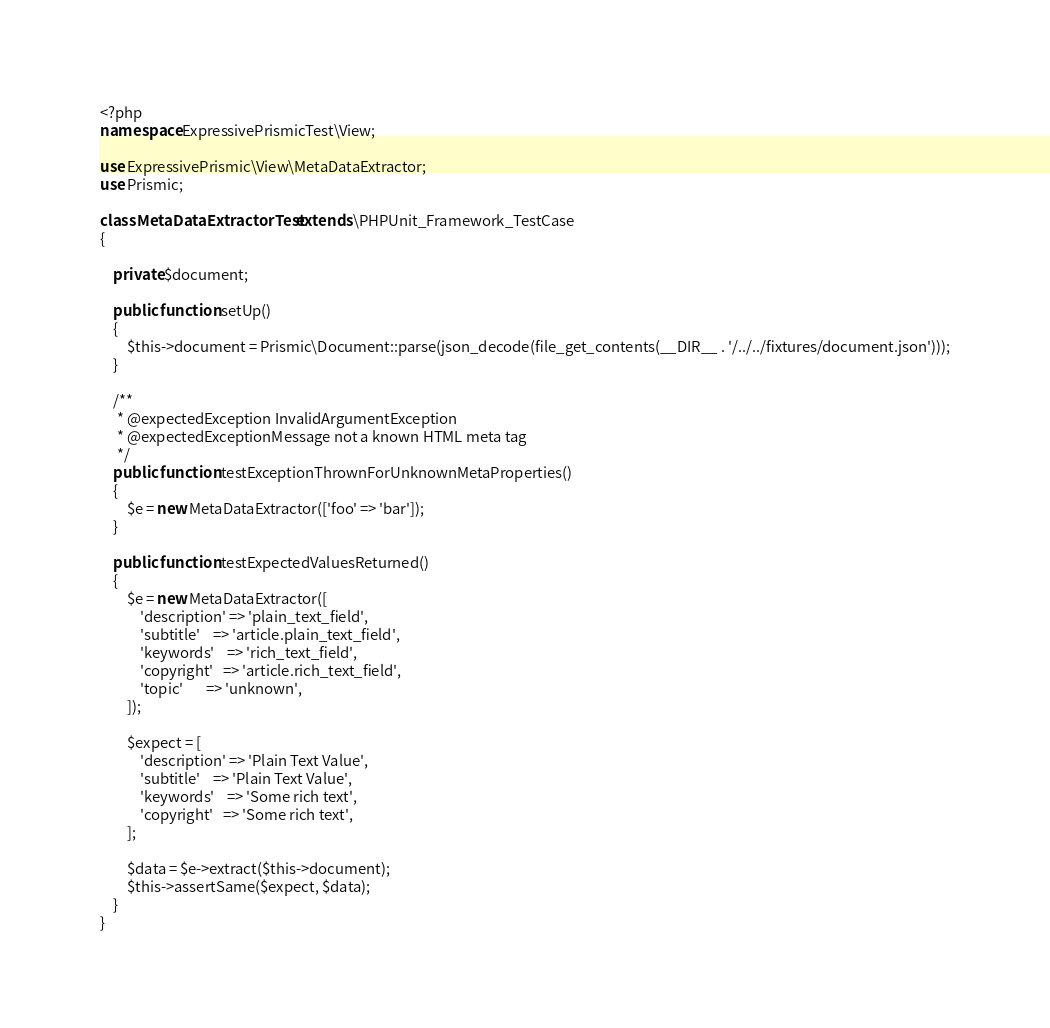Convert code to text. <code><loc_0><loc_0><loc_500><loc_500><_PHP_><?php
namespace ExpressivePrismicTest\View;

use ExpressivePrismic\View\MetaDataExtractor;
use Prismic;

class MetaDataExtractorTest extends \PHPUnit_Framework_TestCase
{

    private $document;

    public function setUp()
    {
        $this->document = Prismic\Document::parse(json_decode(file_get_contents(__DIR__ . '/../../fixtures/document.json')));
    }

    /**
     * @expectedException InvalidArgumentException
     * @expectedExceptionMessage not a known HTML meta tag
     */
    public function testExceptionThrownForUnknownMetaProperties()
    {
        $e = new MetaDataExtractor(['foo' => 'bar']);
    }

    public function testExpectedValuesReturned()
    {
        $e = new MetaDataExtractor([
            'description' => 'plain_text_field',
            'subtitle'    => 'article.plain_text_field',
            'keywords'    => 'rich_text_field',
            'copyright'   => 'article.rich_text_field',
            'topic'       => 'unknown',
        ]);

        $expect = [
            'description' => 'Plain Text Value',
            'subtitle'    => 'Plain Text Value',
            'keywords'    => 'Some rich text',
            'copyright'   => 'Some rich text',
        ];

        $data = $e->extract($this->document);
        $this->assertSame($expect, $data);
    }
}
</code> 